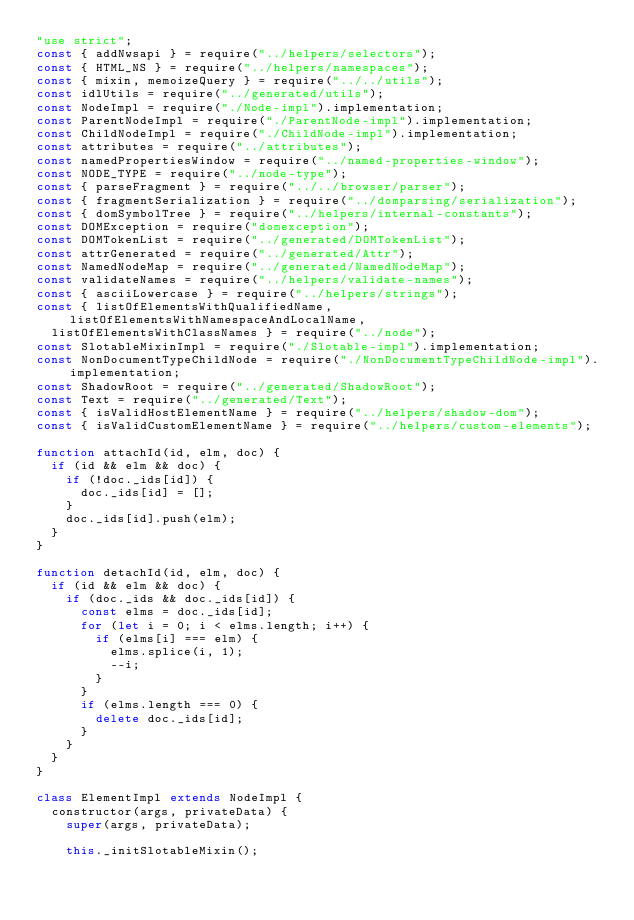<code> <loc_0><loc_0><loc_500><loc_500><_JavaScript_>"use strict";
const { addNwsapi } = require("../helpers/selectors");
const { HTML_NS } = require("../helpers/namespaces");
const { mixin, memoizeQuery } = require("../../utils");
const idlUtils = require("../generated/utils");
const NodeImpl = require("./Node-impl").implementation;
const ParentNodeImpl = require("./ParentNode-impl").implementation;
const ChildNodeImpl = require("./ChildNode-impl").implementation;
const attributes = require("../attributes");
const namedPropertiesWindow = require("../named-properties-window");
const NODE_TYPE = require("../node-type");
const { parseFragment } = require("../../browser/parser");
const { fragmentSerialization } = require("../domparsing/serialization");
const { domSymbolTree } = require("../helpers/internal-constants");
const DOMException = require("domexception");
const DOMTokenList = require("../generated/DOMTokenList");
const attrGenerated = require("../generated/Attr");
const NamedNodeMap = require("../generated/NamedNodeMap");
const validateNames = require("../helpers/validate-names");
const { asciiLowercase } = require("../helpers/strings");
const { listOfElementsWithQualifiedName, listOfElementsWithNamespaceAndLocalName,
  listOfElementsWithClassNames } = require("../node");
const SlotableMixinImpl = require("./Slotable-impl").implementation;
const NonDocumentTypeChildNode = require("./NonDocumentTypeChildNode-impl").implementation;
const ShadowRoot = require("../generated/ShadowRoot");
const Text = require("../generated/Text");
const { isValidHostElementName } = require("../helpers/shadow-dom");
const { isValidCustomElementName } = require("../helpers/custom-elements");

function attachId(id, elm, doc) {
  if (id && elm && doc) {
    if (!doc._ids[id]) {
      doc._ids[id] = [];
    }
    doc._ids[id].push(elm);
  }
}

function detachId(id, elm, doc) {
  if (id && elm && doc) {
    if (doc._ids && doc._ids[id]) {
      const elms = doc._ids[id];
      for (let i = 0; i < elms.length; i++) {
        if (elms[i] === elm) {
          elms.splice(i, 1);
          --i;
        }
      }
      if (elms.length === 0) {
        delete doc._ids[id];
      }
    }
  }
}

class ElementImpl extends NodeImpl {
  constructor(args, privateData) {
    super(args, privateData);

    this._initSlotableMixin();
</code> 